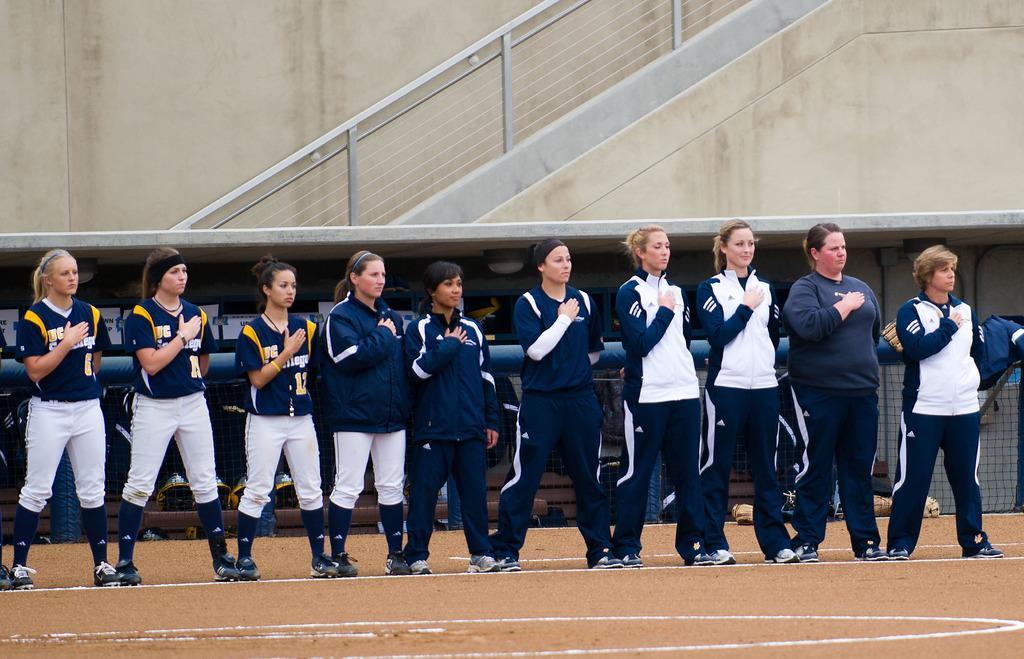Please provide a concise description of this image. In this image we can see group of people standing on the ground wearing uniforms. In the background we can see a fence with a coat placed on it and a staircase. 